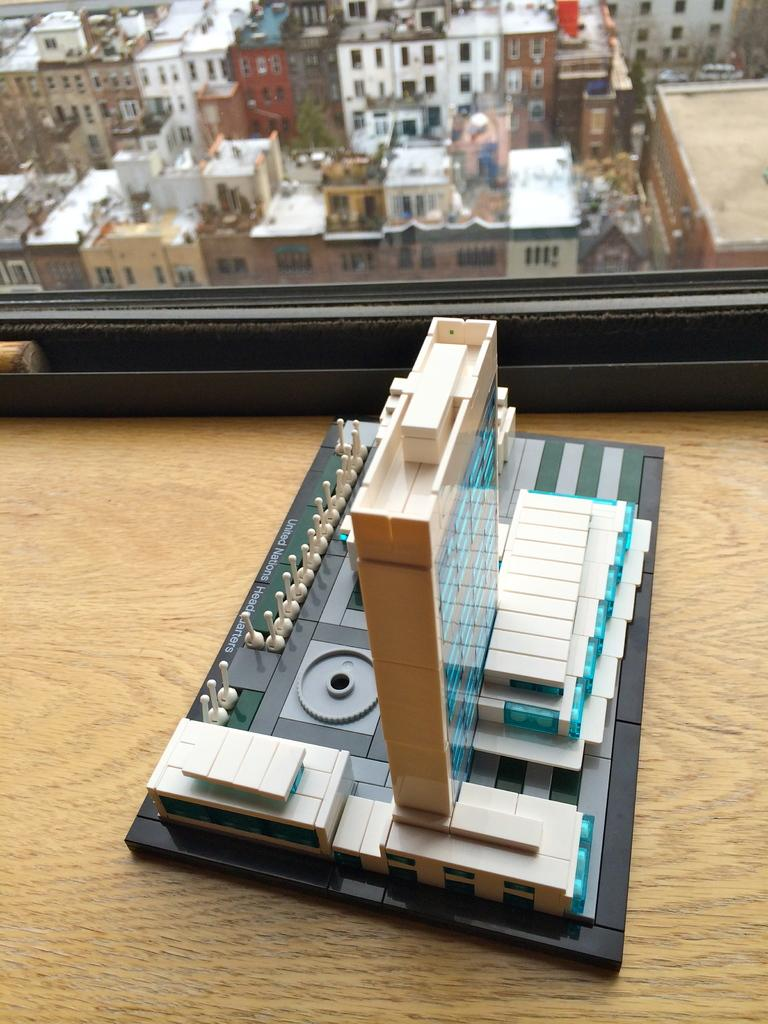What is the main object on the wooden surface in the image? The fact does not specify the object on the wooden surface, so we cannot definitively answer this question. What type of surface is at the top of the image? There is a glass window at the top of the image. What can be seen through the glass window? Buildings are visible through the glass window. How many eyes can be seen on the wooden surface in the image? There are no eyes visible on the wooden surface in the image. What direction is the comb pointing in the image? There is no comb present in the image. 